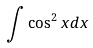Convert formula to latex. <formula><loc_0><loc_0><loc_500><loc_500>\int \cos ^ { 2 } x d x</formula> 